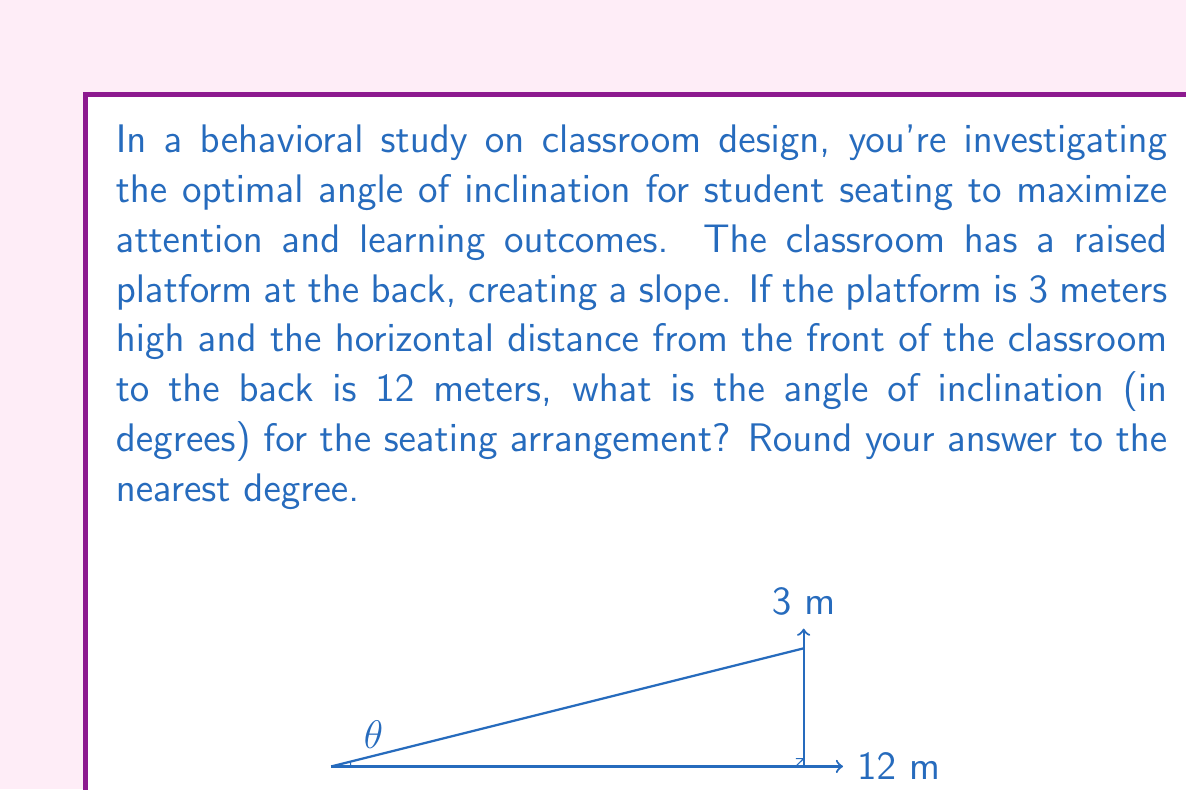Could you help me with this problem? To solve this problem, we'll use trigonometry. The classroom setup forms a right-angled triangle, where:

1. The adjacent side (horizontal distance) is 12 meters
2. The opposite side (height of the platform) is 3 meters
3. We need to find the angle of inclination (θ)

We can use the tangent function to find this angle:

$$\tan(\theta) = \frac{\text{opposite}}{\text{adjacent}}$$

Substituting our values:

$$\tan(\theta) = \frac{3}{12} = \frac{1}{4} = 0.25$$

To find θ, we need to use the inverse tangent (arctan or $\tan^{-1}$):

$$\theta = \tan^{-1}(0.25)$$

Using a calculator or trigonometric tables:

$$\theta \approx 14.0362^\circ$$

Rounding to the nearest degree:

$$\theta \approx 14^\circ$$

This angle represents the optimal inclination for the classroom seating arrangement based on the given dimensions, potentially maximizing attention and learning outcomes in this environment.
Answer: $14^\circ$ 